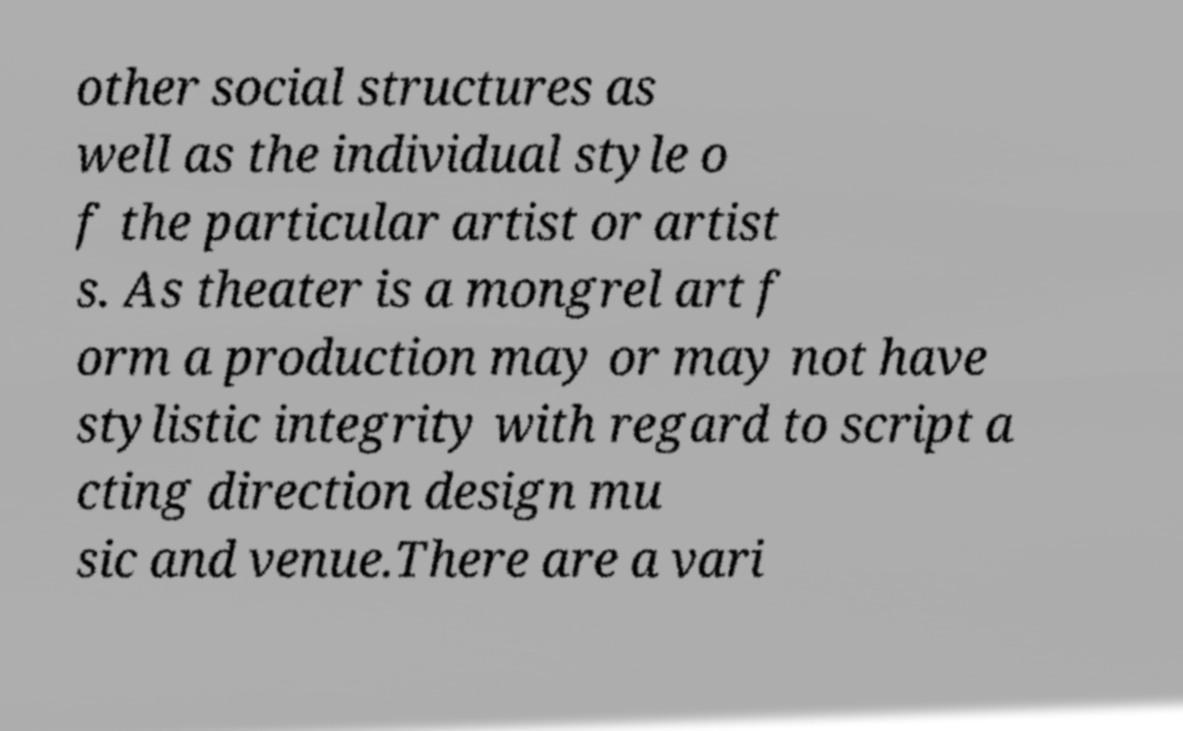Could you extract and type out the text from this image? other social structures as well as the individual style o f the particular artist or artist s. As theater is a mongrel art f orm a production may or may not have stylistic integrity with regard to script a cting direction design mu sic and venue.There are a vari 